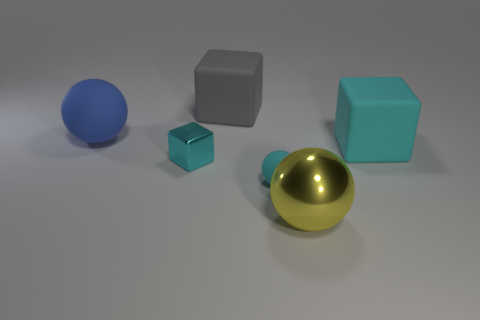Add 2 cyan things. How many objects exist? 8 Subtract all large brown blocks. Subtract all large matte objects. How many objects are left? 3 Add 6 tiny balls. How many tiny balls are left? 7 Add 2 large brown matte blocks. How many large brown matte blocks exist? 2 Subtract 0 red cubes. How many objects are left? 6 